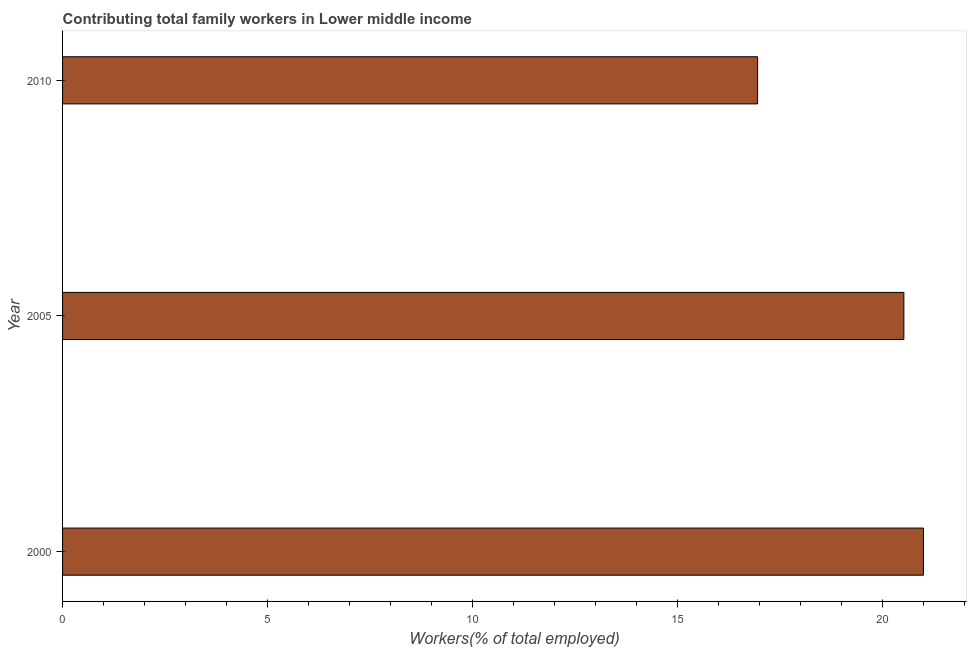Does the graph contain any zero values?
Ensure brevity in your answer.  No. Does the graph contain grids?
Your answer should be compact. No. What is the title of the graph?
Offer a very short reply. Contributing total family workers in Lower middle income. What is the label or title of the X-axis?
Offer a very short reply. Workers(% of total employed). What is the label or title of the Y-axis?
Offer a very short reply. Year. What is the contributing family workers in 2010?
Keep it short and to the point. 16.95. Across all years, what is the maximum contributing family workers?
Provide a short and direct response. 20.99. Across all years, what is the minimum contributing family workers?
Make the answer very short. 16.95. In which year was the contributing family workers maximum?
Give a very brief answer. 2000. What is the sum of the contributing family workers?
Provide a succinct answer. 58.45. What is the difference between the contributing family workers in 2005 and 2010?
Your response must be concise. 3.57. What is the average contributing family workers per year?
Your response must be concise. 19.48. What is the median contributing family workers?
Offer a very short reply. 20.51. Do a majority of the years between 2010 and 2005 (inclusive) have contributing family workers greater than 8 %?
Offer a terse response. No. What is the ratio of the contributing family workers in 2005 to that in 2010?
Your response must be concise. 1.21. Is the contributing family workers in 2000 less than that in 2005?
Offer a terse response. No. Is the difference between the contributing family workers in 2000 and 2005 greater than the difference between any two years?
Offer a very short reply. No. What is the difference between the highest and the second highest contributing family workers?
Keep it short and to the point. 0.48. Is the sum of the contributing family workers in 2000 and 2005 greater than the maximum contributing family workers across all years?
Your answer should be compact. Yes. What is the difference between the highest and the lowest contributing family workers?
Give a very brief answer. 4.04. In how many years, is the contributing family workers greater than the average contributing family workers taken over all years?
Provide a succinct answer. 2. How many years are there in the graph?
Ensure brevity in your answer.  3. What is the difference between two consecutive major ticks on the X-axis?
Provide a short and direct response. 5. What is the Workers(% of total employed) in 2000?
Offer a very short reply. 20.99. What is the Workers(% of total employed) in 2005?
Your answer should be very brief. 20.51. What is the Workers(% of total employed) in 2010?
Offer a very short reply. 16.95. What is the difference between the Workers(% of total employed) in 2000 and 2005?
Make the answer very short. 0.48. What is the difference between the Workers(% of total employed) in 2000 and 2010?
Provide a succinct answer. 4.04. What is the difference between the Workers(% of total employed) in 2005 and 2010?
Keep it short and to the point. 3.57. What is the ratio of the Workers(% of total employed) in 2000 to that in 2005?
Your answer should be compact. 1.02. What is the ratio of the Workers(% of total employed) in 2000 to that in 2010?
Your response must be concise. 1.24. What is the ratio of the Workers(% of total employed) in 2005 to that in 2010?
Make the answer very short. 1.21. 